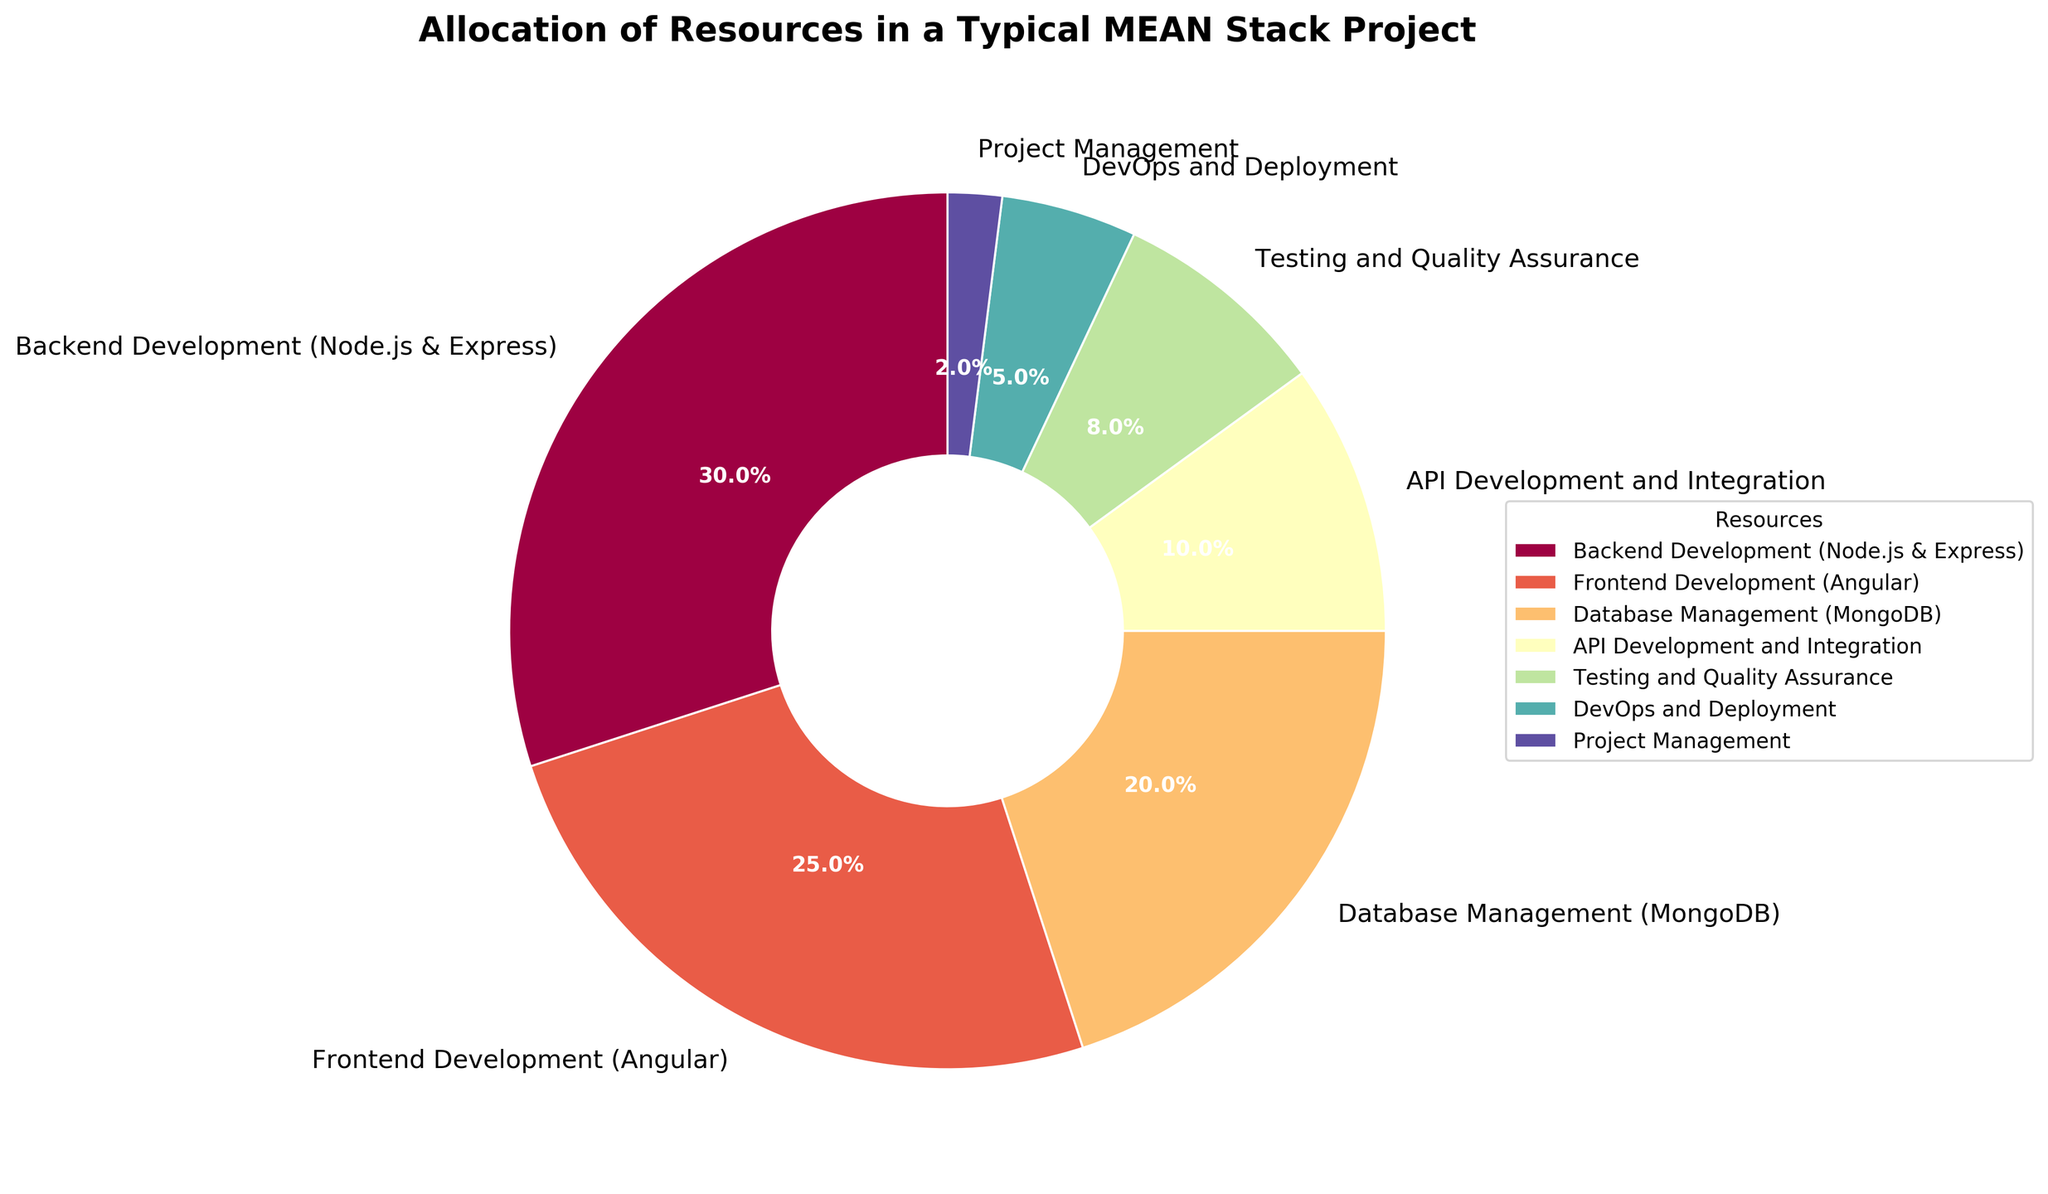Which resource requires the highest allocation? In the pie chart, the resource with the largest segment represents the highest allocation. Backend Development (Node.js & Express) has the largest percentage at 30%.
Answer: Backend Development (Node.js & Express) Which resources combined account for less than 10% of the total allocation? By checking the individual segments, we find DevOps and Deployment at 5% and Project Management at 2%, collectively making up 7%, which is less than 10%.
Answer: DevOps and Deployment, Project Management What is the difference in the allocation percentage between Backend Development and Frontend Development? Backend Development is allocated 30%, and Frontend Development is at 25%. The difference is calculated as 30% - 25% = 5%.
Answer: 5% Which resource has the least allocation? The smallest segment in the pie chart represents the least allocation. Project Management allocates the least at 2%.
Answer: Project Management How much percentage is allocated collectively to Database Management and API Development and Integration? Database Management has 20% allocation, and API Development and Integration is at 10%. Adding them together gives 20% + 10% = 30%.
Answer: 30% Are there any resources that have an equal allocation percentage? By checking the segments, no two resources have equal allocation percentages in the given pie chart.
Answer: No Is Testing and Quality Assurance allocated more resources than DevOps and Deployment? Testing and Quality Assurance is allocated 8%, while DevOps and Deployment is allocated 5%. 8% is greater than 5%, so the answer is yes.
Answer: Yes 